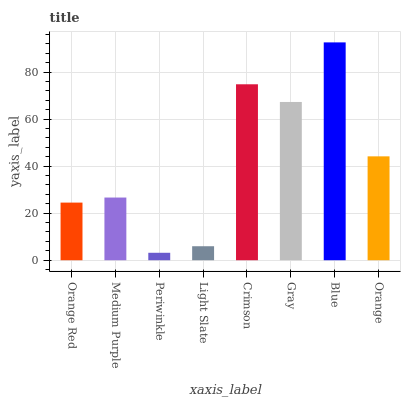Is Periwinkle the minimum?
Answer yes or no. Yes. Is Blue the maximum?
Answer yes or no. Yes. Is Medium Purple the minimum?
Answer yes or no. No. Is Medium Purple the maximum?
Answer yes or no. No. Is Medium Purple greater than Orange Red?
Answer yes or no. Yes. Is Orange Red less than Medium Purple?
Answer yes or no. Yes. Is Orange Red greater than Medium Purple?
Answer yes or no. No. Is Medium Purple less than Orange Red?
Answer yes or no. No. Is Orange the high median?
Answer yes or no. Yes. Is Medium Purple the low median?
Answer yes or no. Yes. Is Light Slate the high median?
Answer yes or no. No. Is Crimson the low median?
Answer yes or no. No. 